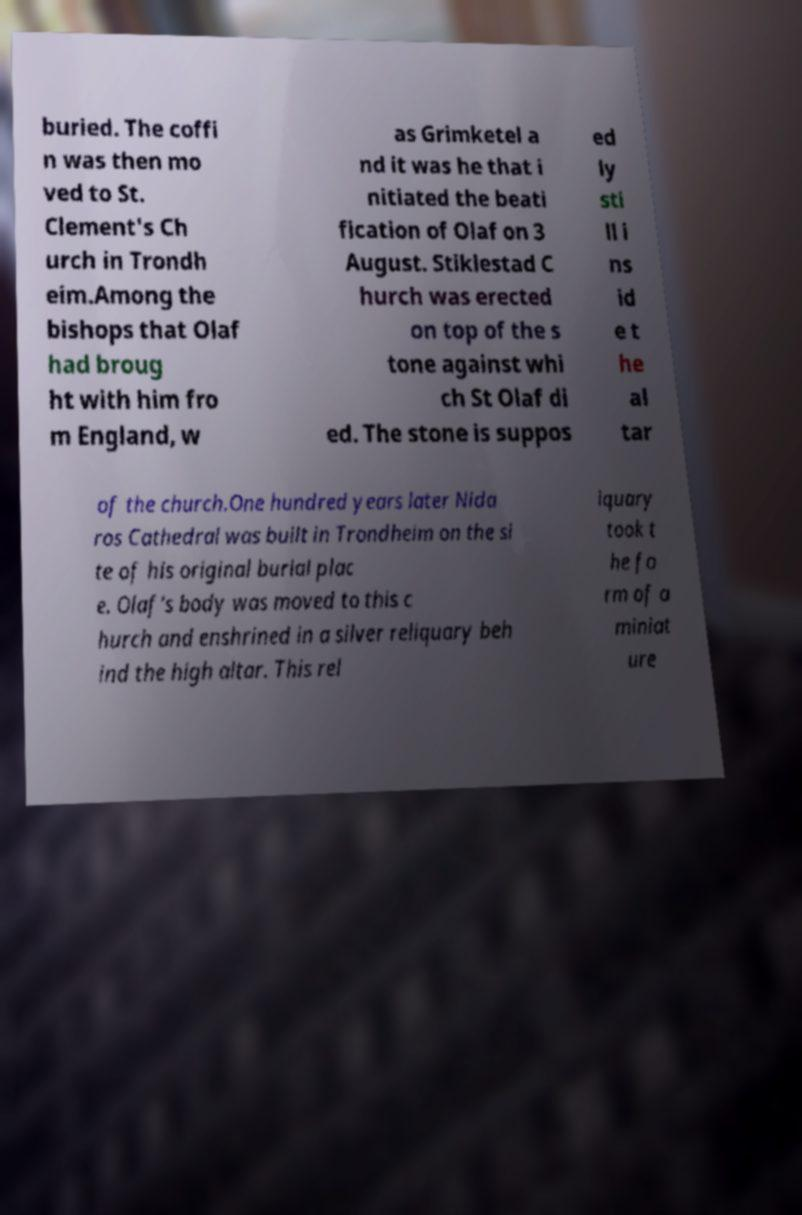There's text embedded in this image that I need extracted. Can you transcribe it verbatim? buried. The coffi n was then mo ved to St. Clement's Ch urch in Trondh eim.Among the bishops that Olaf had broug ht with him fro m England, w as Grimketel a nd it was he that i nitiated the beati fication of Olaf on 3 August. Stiklestad C hurch was erected on top of the s tone against whi ch St Olaf di ed. The stone is suppos ed ly sti ll i ns id e t he al tar of the church.One hundred years later Nida ros Cathedral was built in Trondheim on the si te of his original burial plac e. Olaf's body was moved to this c hurch and enshrined in a silver reliquary beh ind the high altar. This rel iquary took t he fo rm of a miniat ure 